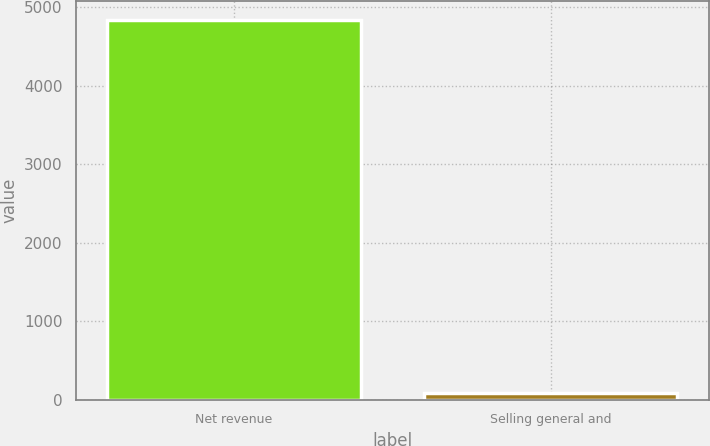<chart> <loc_0><loc_0><loc_500><loc_500><bar_chart><fcel>Net revenue<fcel>Selling general and<nl><fcel>4837<fcel>87<nl></chart> 